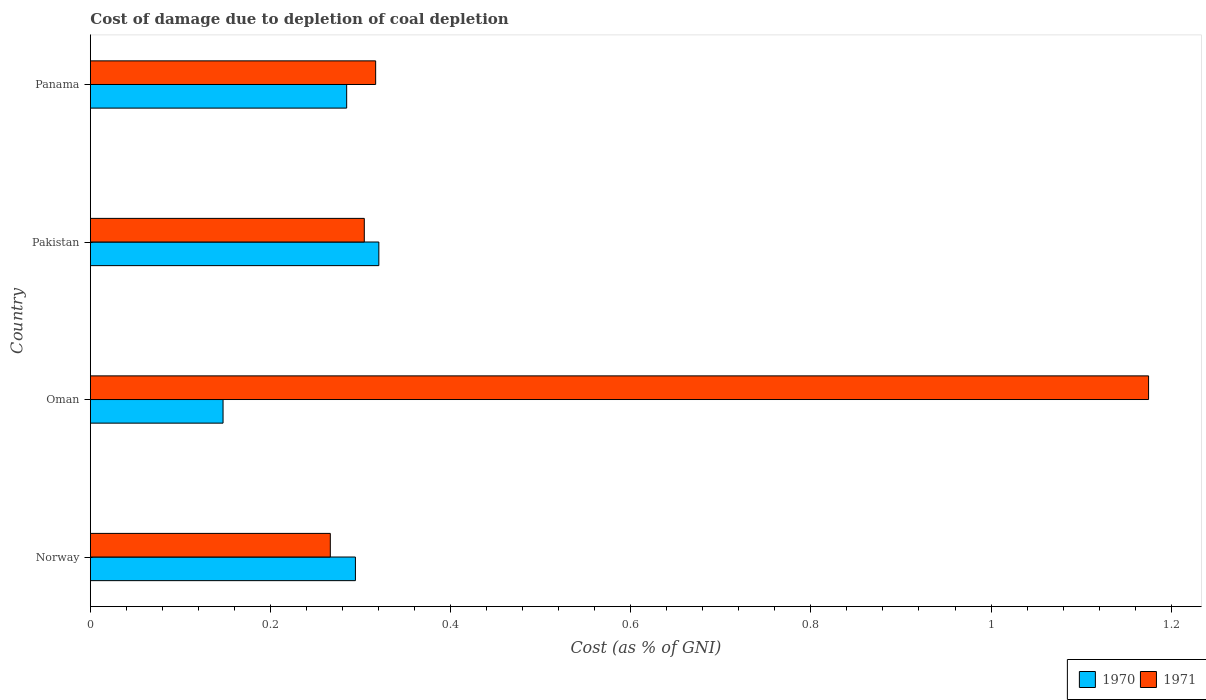Are the number of bars on each tick of the Y-axis equal?
Keep it short and to the point. Yes. How many bars are there on the 1st tick from the bottom?
Your answer should be compact. 2. What is the label of the 1st group of bars from the top?
Give a very brief answer. Panama. In how many cases, is the number of bars for a given country not equal to the number of legend labels?
Provide a succinct answer. 0. What is the cost of damage caused due to coal depletion in 1970 in Pakistan?
Give a very brief answer. 0.32. Across all countries, what is the maximum cost of damage caused due to coal depletion in 1970?
Provide a succinct answer. 0.32. Across all countries, what is the minimum cost of damage caused due to coal depletion in 1971?
Offer a terse response. 0.27. In which country was the cost of damage caused due to coal depletion in 1970 minimum?
Give a very brief answer. Oman. What is the total cost of damage caused due to coal depletion in 1971 in the graph?
Provide a succinct answer. 2.06. What is the difference between the cost of damage caused due to coal depletion in 1971 in Norway and that in Oman?
Make the answer very short. -0.91. What is the difference between the cost of damage caused due to coal depletion in 1971 in Oman and the cost of damage caused due to coal depletion in 1970 in Norway?
Make the answer very short. 0.88. What is the average cost of damage caused due to coal depletion in 1971 per country?
Offer a very short reply. 0.52. What is the difference between the cost of damage caused due to coal depletion in 1970 and cost of damage caused due to coal depletion in 1971 in Norway?
Provide a succinct answer. 0.03. What is the ratio of the cost of damage caused due to coal depletion in 1971 in Norway to that in Pakistan?
Your response must be concise. 0.88. What is the difference between the highest and the second highest cost of damage caused due to coal depletion in 1970?
Offer a terse response. 0.03. What is the difference between the highest and the lowest cost of damage caused due to coal depletion in 1971?
Offer a very short reply. 0.91. In how many countries, is the cost of damage caused due to coal depletion in 1971 greater than the average cost of damage caused due to coal depletion in 1971 taken over all countries?
Ensure brevity in your answer.  1. What does the 1st bar from the top in Panama represents?
Your answer should be compact. 1971. Are all the bars in the graph horizontal?
Ensure brevity in your answer.  Yes. What is the title of the graph?
Your answer should be compact. Cost of damage due to depletion of coal depletion. Does "1963" appear as one of the legend labels in the graph?
Provide a succinct answer. No. What is the label or title of the X-axis?
Offer a terse response. Cost (as % of GNI). What is the label or title of the Y-axis?
Give a very brief answer. Country. What is the Cost (as % of GNI) in 1970 in Norway?
Give a very brief answer. 0.29. What is the Cost (as % of GNI) of 1971 in Norway?
Give a very brief answer. 0.27. What is the Cost (as % of GNI) in 1970 in Oman?
Provide a short and direct response. 0.15. What is the Cost (as % of GNI) in 1971 in Oman?
Offer a terse response. 1.17. What is the Cost (as % of GNI) of 1970 in Pakistan?
Keep it short and to the point. 0.32. What is the Cost (as % of GNI) in 1971 in Pakistan?
Ensure brevity in your answer.  0.3. What is the Cost (as % of GNI) of 1970 in Panama?
Give a very brief answer. 0.28. What is the Cost (as % of GNI) of 1971 in Panama?
Ensure brevity in your answer.  0.32. Across all countries, what is the maximum Cost (as % of GNI) of 1970?
Your answer should be compact. 0.32. Across all countries, what is the maximum Cost (as % of GNI) in 1971?
Give a very brief answer. 1.17. Across all countries, what is the minimum Cost (as % of GNI) in 1970?
Your answer should be very brief. 0.15. Across all countries, what is the minimum Cost (as % of GNI) of 1971?
Provide a succinct answer. 0.27. What is the total Cost (as % of GNI) in 1970 in the graph?
Provide a succinct answer. 1.05. What is the total Cost (as % of GNI) in 1971 in the graph?
Your answer should be very brief. 2.06. What is the difference between the Cost (as % of GNI) in 1970 in Norway and that in Oman?
Provide a short and direct response. 0.15. What is the difference between the Cost (as % of GNI) in 1971 in Norway and that in Oman?
Your answer should be very brief. -0.91. What is the difference between the Cost (as % of GNI) in 1970 in Norway and that in Pakistan?
Make the answer very short. -0.03. What is the difference between the Cost (as % of GNI) of 1971 in Norway and that in Pakistan?
Provide a succinct answer. -0.04. What is the difference between the Cost (as % of GNI) in 1970 in Norway and that in Panama?
Keep it short and to the point. 0.01. What is the difference between the Cost (as % of GNI) of 1971 in Norway and that in Panama?
Give a very brief answer. -0.05. What is the difference between the Cost (as % of GNI) in 1970 in Oman and that in Pakistan?
Ensure brevity in your answer.  -0.17. What is the difference between the Cost (as % of GNI) of 1971 in Oman and that in Pakistan?
Your response must be concise. 0.87. What is the difference between the Cost (as % of GNI) in 1970 in Oman and that in Panama?
Provide a short and direct response. -0.14. What is the difference between the Cost (as % of GNI) in 1971 in Oman and that in Panama?
Give a very brief answer. 0.86. What is the difference between the Cost (as % of GNI) of 1970 in Pakistan and that in Panama?
Offer a terse response. 0.04. What is the difference between the Cost (as % of GNI) in 1971 in Pakistan and that in Panama?
Keep it short and to the point. -0.01. What is the difference between the Cost (as % of GNI) in 1970 in Norway and the Cost (as % of GNI) in 1971 in Oman?
Keep it short and to the point. -0.88. What is the difference between the Cost (as % of GNI) in 1970 in Norway and the Cost (as % of GNI) in 1971 in Pakistan?
Your response must be concise. -0.01. What is the difference between the Cost (as % of GNI) in 1970 in Norway and the Cost (as % of GNI) in 1971 in Panama?
Your answer should be compact. -0.02. What is the difference between the Cost (as % of GNI) of 1970 in Oman and the Cost (as % of GNI) of 1971 in Pakistan?
Provide a short and direct response. -0.16. What is the difference between the Cost (as % of GNI) in 1970 in Oman and the Cost (as % of GNI) in 1971 in Panama?
Your answer should be very brief. -0.17. What is the difference between the Cost (as % of GNI) of 1970 in Pakistan and the Cost (as % of GNI) of 1971 in Panama?
Your answer should be compact. 0. What is the average Cost (as % of GNI) of 1970 per country?
Give a very brief answer. 0.26. What is the average Cost (as % of GNI) in 1971 per country?
Provide a short and direct response. 0.52. What is the difference between the Cost (as % of GNI) of 1970 and Cost (as % of GNI) of 1971 in Norway?
Offer a very short reply. 0.03. What is the difference between the Cost (as % of GNI) of 1970 and Cost (as % of GNI) of 1971 in Oman?
Provide a succinct answer. -1.03. What is the difference between the Cost (as % of GNI) of 1970 and Cost (as % of GNI) of 1971 in Pakistan?
Offer a terse response. 0.02. What is the difference between the Cost (as % of GNI) of 1970 and Cost (as % of GNI) of 1971 in Panama?
Your answer should be compact. -0.03. What is the ratio of the Cost (as % of GNI) in 1970 in Norway to that in Oman?
Make the answer very short. 2. What is the ratio of the Cost (as % of GNI) of 1971 in Norway to that in Oman?
Offer a terse response. 0.23. What is the ratio of the Cost (as % of GNI) in 1970 in Norway to that in Pakistan?
Make the answer very short. 0.92. What is the ratio of the Cost (as % of GNI) in 1971 in Norway to that in Pakistan?
Offer a very short reply. 0.88. What is the ratio of the Cost (as % of GNI) of 1970 in Norway to that in Panama?
Offer a terse response. 1.03. What is the ratio of the Cost (as % of GNI) in 1971 in Norway to that in Panama?
Ensure brevity in your answer.  0.84. What is the ratio of the Cost (as % of GNI) in 1970 in Oman to that in Pakistan?
Give a very brief answer. 0.46. What is the ratio of the Cost (as % of GNI) in 1971 in Oman to that in Pakistan?
Offer a very short reply. 3.86. What is the ratio of the Cost (as % of GNI) of 1970 in Oman to that in Panama?
Your answer should be compact. 0.52. What is the ratio of the Cost (as % of GNI) in 1971 in Oman to that in Panama?
Keep it short and to the point. 3.71. What is the ratio of the Cost (as % of GNI) of 1970 in Pakistan to that in Panama?
Offer a terse response. 1.13. What is the ratio of the Cost (as % of GNI) in 1971 in Pakistan to that in Panama?
Your response must be concise. 0.96. What is the difference between the highest and the second highest Cost (as % of GNI) in 1970?
Your answer should be very brief. 0.03. What is the difference between the highest and the second highest Cost (as % of GNI) in 1971?
Your answer should be very brief. 0.86. What is the difference between the highest and the lowest Cost (as % of GNI) of 1970?
Offer a very short reply. 0.17. What is the difference between the highest and the lowest Cost (as % of GNI) of 1971?
Make the answer very short. 0.91. 